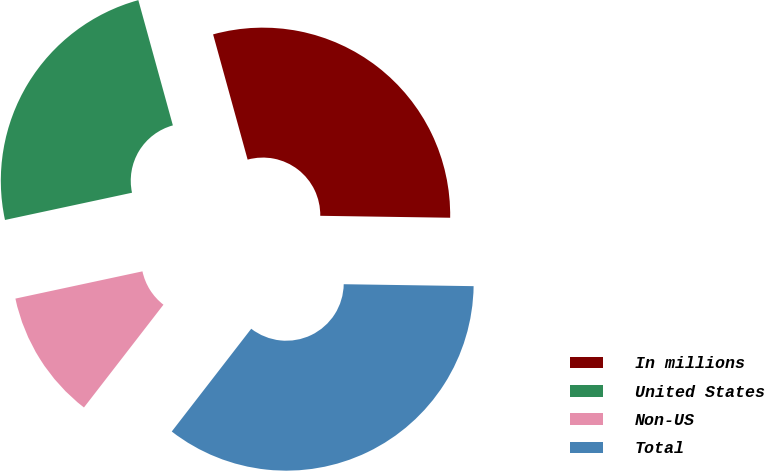Convert chart to OTSL. <chart><loc_0><loc_0><loc_500><loc_500><pie_chart><fcel>In millions<fcel>United States<fcel>Non-US<fcel>Total<nl><fcel>29.52%<fcel>24.08%<fcel>11.16%<fcel>35.24%<nl></chart> 